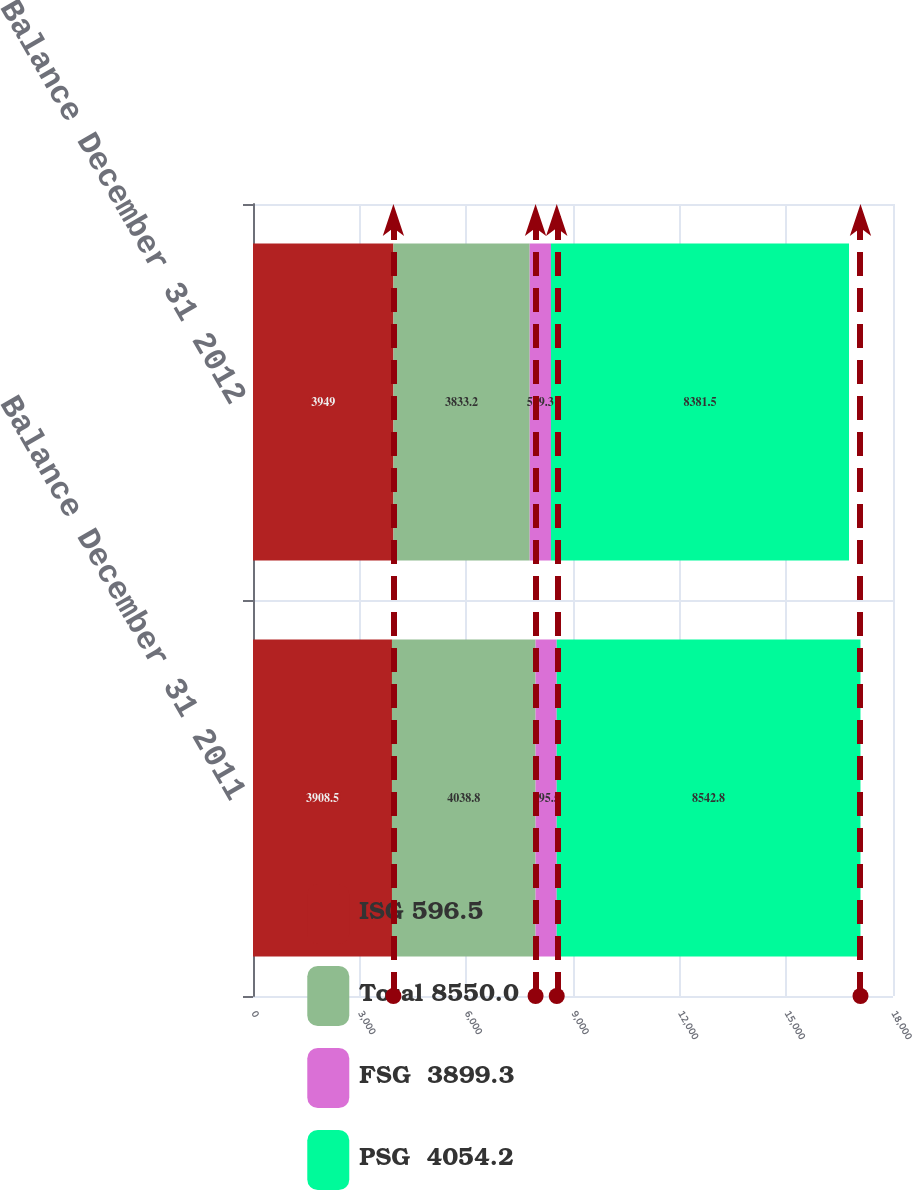Convert chart to OTSL. <chart><loc_0><loc_0><loc_500><loc_500><stacked_bar_chart><ecel><fcel>Balance December 31 2011<fcel>Balance December 31 2012<nl><fcel>ISG 596.5<fcel>3908.5<fcel>3949<nl><fcel>Total 8550.0<fcel>4038.8<fcel>3833.2<nl><fcel>FSG  3899.3<fcel>595.5<fcel>599.3<nl><fcel>PSG  4054.2<fcel>8542.8<fcel>8381.5<nl></chart> 